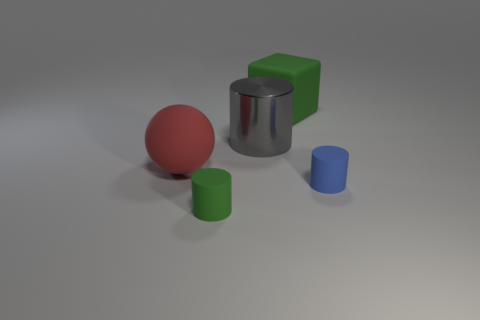How many big yellow balls are there?
Keep it short and to the point. 0. What is the color of the rubber block that is the same size as the rubber sphere?
Give a very brief answer. Green. Is the green thing in front of the big red rubber thing made of the same material as the cylinder that is behind the red sphere?
Your answer should be very brief. No. There is a rubber cylinder that is behind the green rubber object in front of the big gray object; what size is it?
Your answer should be compact. Small. There is a green thing left of the green rubber block; what material is it?
Keep it short and to the point. Rubber. How many things are either green rubber things that are in front of the big gray object or things behind the big sphere?
Your answer should be very brief. 3. There is a tiny green object that is the same shape as the gray metallic thing; what material is it?
Provide a succinct answer. Rubber. Does the matte cylinder to the left of the green rubber block have the same color as the big thing behind the large cylinder?
Offer a very short reply. Yes. Is there a red matte sphere of the same size as the green rubber block?
Your response must be concise. Yes. What is the cylinder that is left of the blue cylinder and behind the small green object made of?
Your answer should be compact. Metal. 